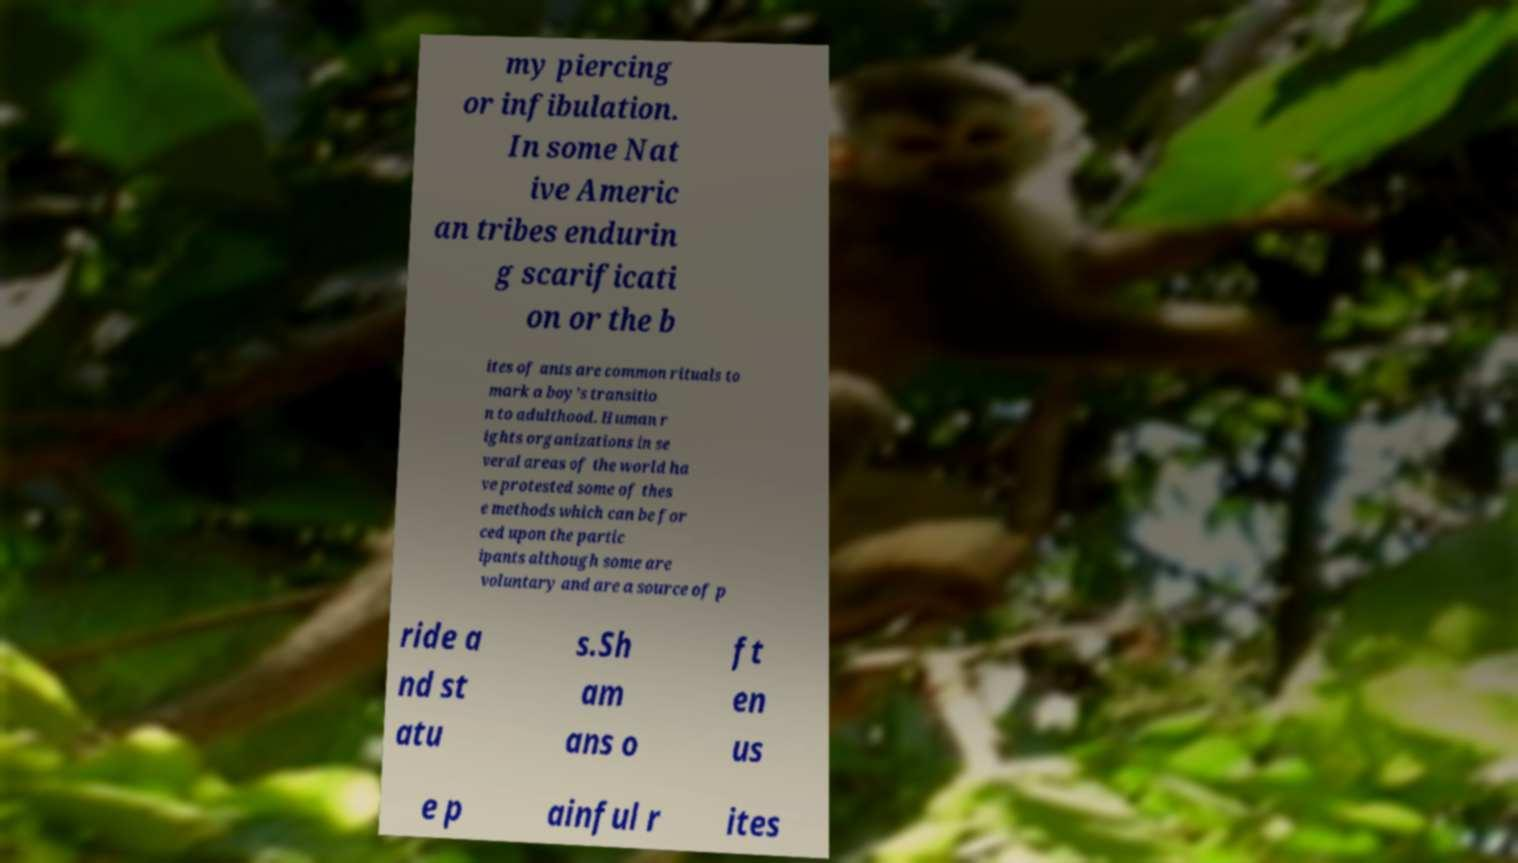There's text embedded in this image that I need extracted. Can you transcribe it verbatim? my piercing or infibulation. In some Nat ive Americ an tribes endurin g scarificati on or the b ites of ants are common rituals to mark a boy's transitio n to adulthood. Human r ights organizations in se veral areas of the world ha ve protested some of thes e methods which can be for ced upon the partic ipants although some are voluntary and are a source of p ride a nd st atu s.Sh am ans o ft en us e p ainful r ites 